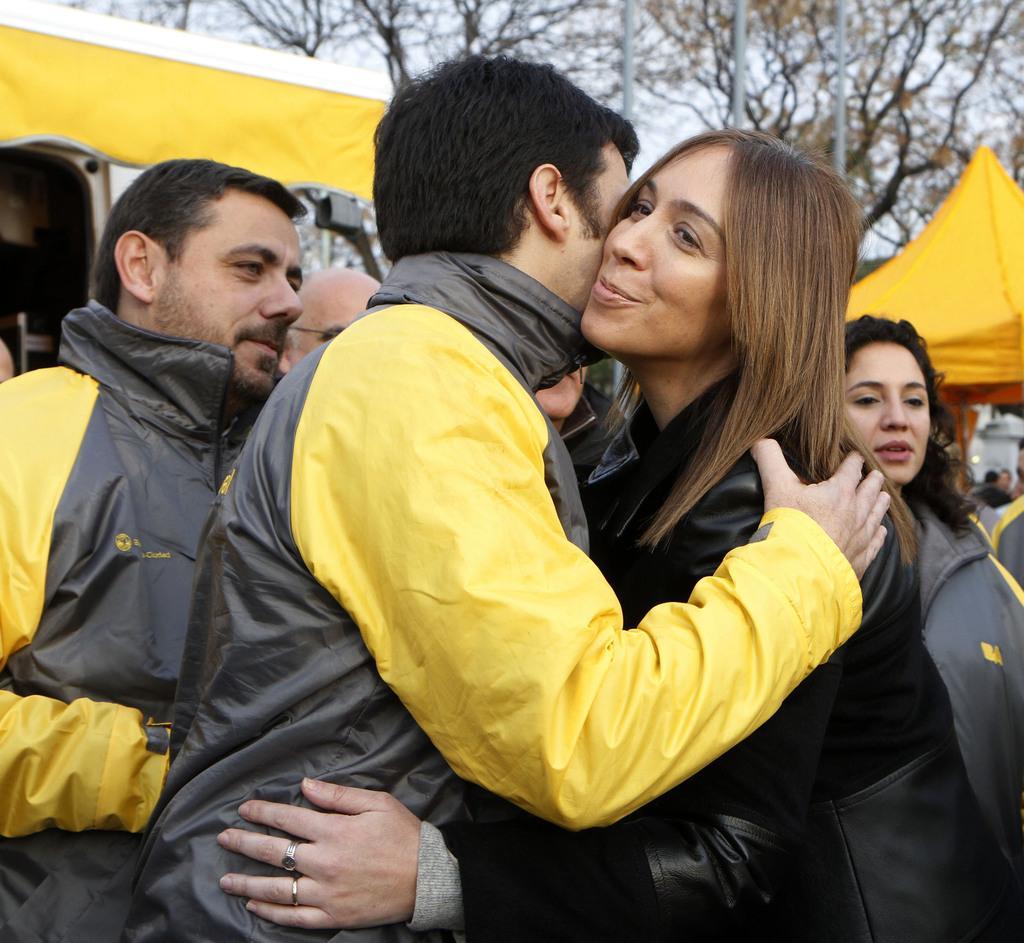Describe this image in one or two sentences. In the image we can see there are people standing, wearing clothes and the right side woman is wearing finger rings. Here we can see tents, trees and poles. 